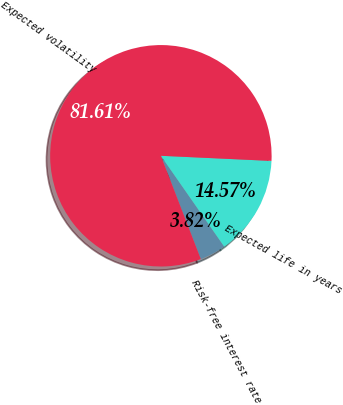<chart> <loc_0><loc_0><loc_500><loc_500><pie_chart><fcel>Risk-free interest rate<fcel>Expected life in years<fcel>Expected volatility<nl><fcel>3.82%<fcel>14.57%<fcel>81.61%<nl></chart> 